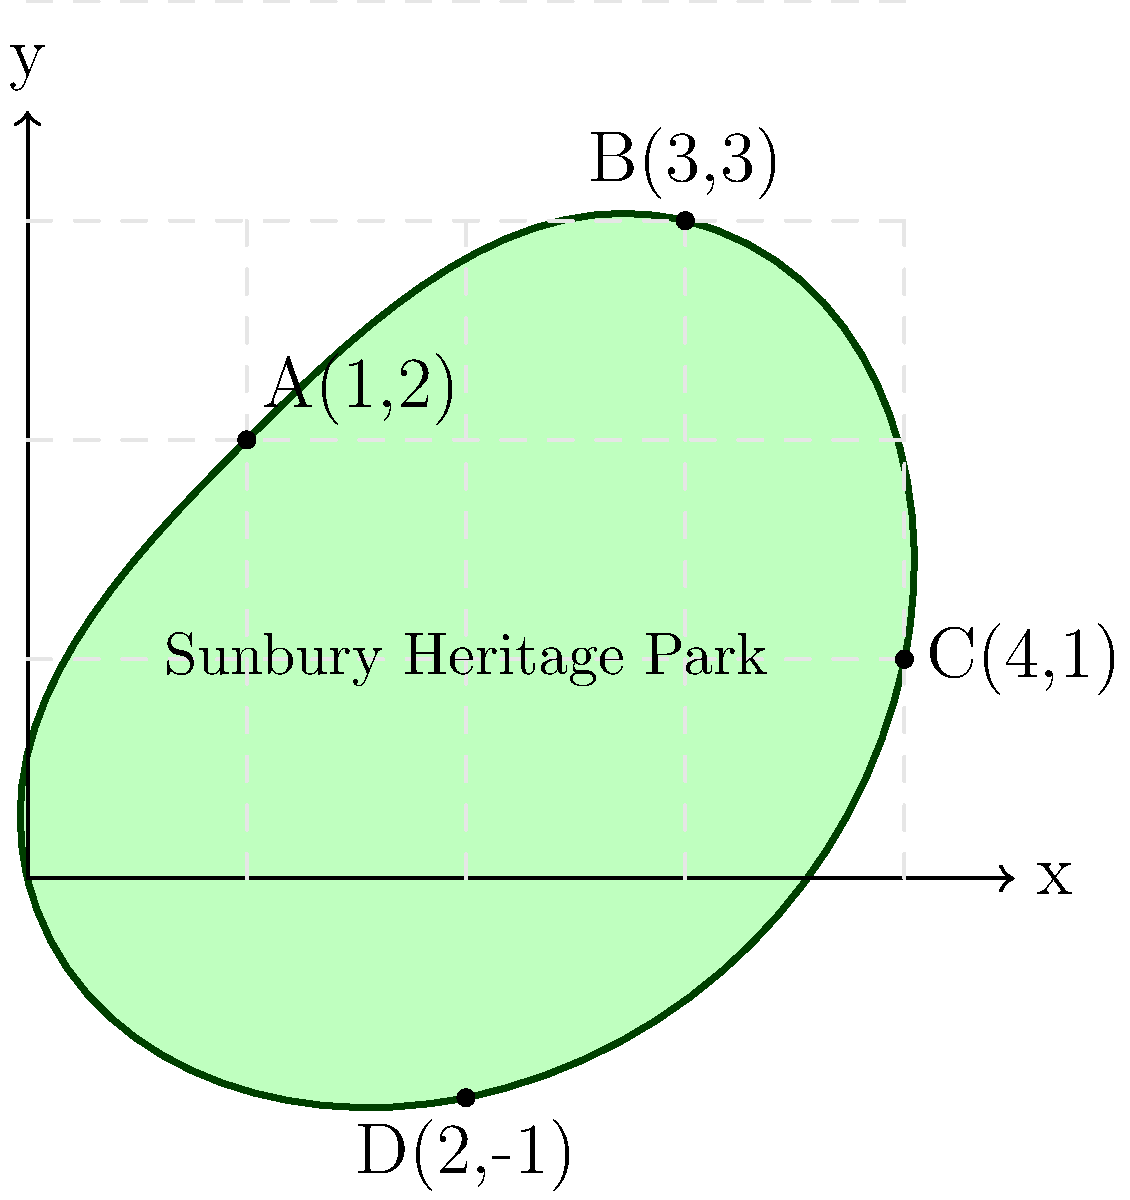The Sunbury Heritage Park, a cherished green space in our historic town, has an irregular shape as shown in the diagram. The park's boundary can be approximated by the function $y = f(x)$ from $x = 0$ to $x = 4$, where:

$f(x) = \begin{cases}
2x & \text{for } 0 \leq x < 1 \\
-0.5x^2 + 3x - 0.5 & \text{for } 1 \leq x < 3 \\
-x + 5 & \text{for } 3 \leq x \leq 4
\end{cases}$

Calculate the area of Sunbury Heritage Park using integration techniques. To find the area of the park, we need to integrate the given piecewise function over the interval $[0, 4]$. Let's break this down step-by-step:

1) The area is given by the definite integral:

   $$A = \int_0^4 f(x) dx$$

2) We need to split this integral into three parts based on the piecewise function:

   $$A = \int_0^1 2x dx + \int_1^3 (-0.5x^2 + 3x - 0.5) dx + \int_3^4 (-x + 5) dx$$

3) Let's solve each integral:

   a) $\int_0^1 2x dx = [x^2]_0^1 = 1 - 0 = 1$

   b) $\int_1^3 (-0.5x^2 + 3x - 0.5) dx = [-\frac{1}{6}x^3 + \frac{3}{2}x^2 - 0.5x]_1^3$
      $= [-\frac{9}{2} + \frac{27}{2} - 1.5] - [-\frac{1}{6} + \frac{3}{2} - 0.5]$
      $= 5.5 - 0.8333 = 4.6667$

   c) $\int_3^4 (-x + 5) dx = [-\frac{1}{2}x^2 + 5x]_3^4$
      $= [-8 + 20] - [-4.5 + 15] = 12 - 10.5 = 1.5$

4) The total area is the sum of these three parts:

   $$A = 1 + 4.6667 + 1.5 = 7.1667$$

Therefore, the area of Sunbury Heritage Park is approximately 7.1667 square units.
Answer: 7.1667 square units 